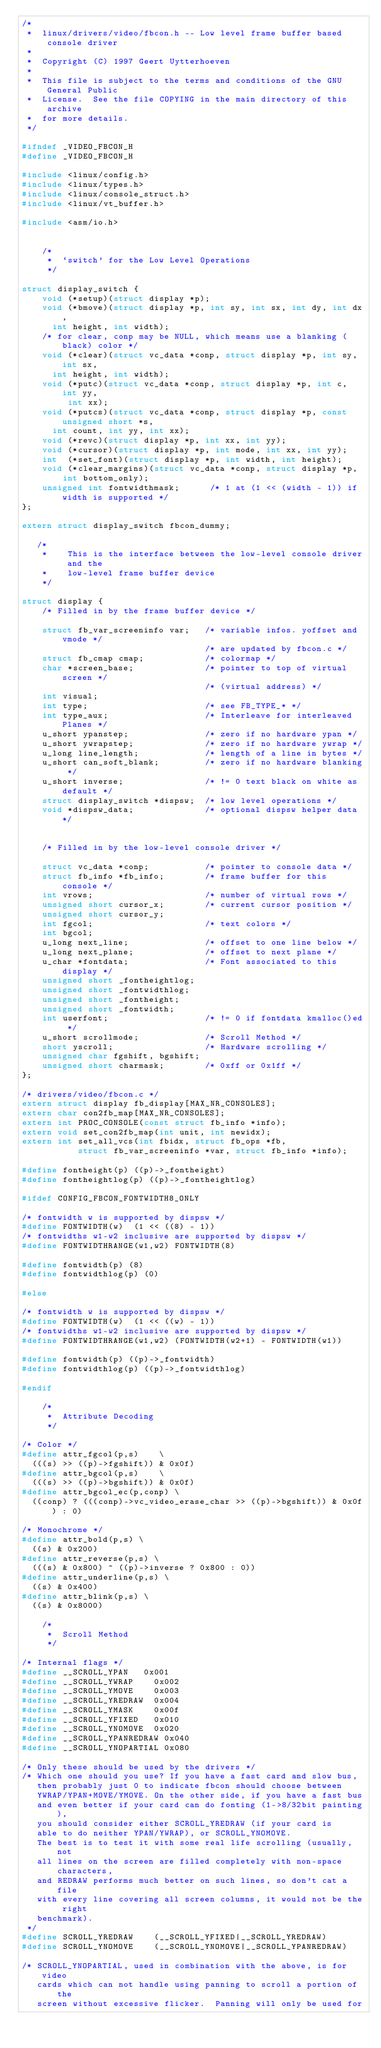Convert code to text. <code><loc_0><loc_0><loc_500><loc_500><_C_>/*
 *  linux/drivers/video/fbcon.h -- Low level frame buffer based console driver
 *
 *	Copyright (C) 1997 Geert Uytterhoeven
 *
 *  This file is subject to the terms and conditions of the GNU General Public
 *  License.  See the file COPYING in the main directory of this archive
 *  for more details.
 */

#ifndef _VIDEO_FBCON_H
#define _VIDEO_FBCON_H

#include <linux/config.h>
#include <linux/types.h>
#include <linux/console_struct.h>
#include <linux/vt_buffer.h>

#include <asm/io.h>


    /*                                  
     *  `switch' for the Low Level Operations
     */
 
struct display_switch {                                                
    void (*setup)(struct display *p);
    void (*bmove)(struct display *p, int sy, int sx, int dy, int dx,
		  int height, int width);
    /* for clear, conp may be NULL, which means use a blanking (black) color */
    void (*clear)(struct vc_data *conp, struct display *p, int sy, int sx,
		  int height, int width);
    void (*putc)(struct vc_data *conp, struct display *p, int c, int yy,
    		 int xx);
    void (*putcs)(struct vc_data *conp, struct display *p, const unsigned short *s,
		  int count, int yy, int xx);     
    void (*revc)(struct display *p, int xx, int yy);
    void (*cursor)(struct display *p, int mode, int xx, int yy);
    int  (*set_font)(struct display *p, int width, int height);
    void (*clear_margins)(struct vc_data *conp, struct display *p,
			  int bottom_only);
    unsigned int fontwidthmask;      /* 1 at (1 << (width - 1)) if width is supported */
}; 

extern struct display_switch fbcon_dummy;

   /*
    *    This is the interface between the low-level console driver and the
    *    low-level frame buffer device
    */

struct display {
    /* Filled in by the frame buffer device */

    struct fb_var_screeninfo var;   /* variable infos. yoffset and vmode */
                                    /* are updated by fbcon.c */
    struct fb_cmap cmap;            /* colormap */
    char *screen_base;              /* pointer to top of virtual screen */    
                                    /* (virtual address) */
    int visual;
    int type;                       /* see FB_TYPE_* */
    int type_aux;                   /* Interleave for interleaved Planes */
    u_short ypanstep;               /* zero if no hardware ypan */
    u_short ywrapstep;              /* zero if no hardware ywrap */
    u_long line_length;             /* length of a line in bytes */
    u_short can_soft_blank;         /* zero if no hardware blanking */
    u_short inverse;                /* != 0 text black on white as default */
    struct display_switch *dispsw;  /* low level operations */
    void *dispsw_data;              /* optional dispsw helper data */


    /* Filled in by the low-level console driver */

    struct vc_data *conp;           /* pointer to console data */
    struct fb_info *fb_info;        /* frame buffer for this console */
    int vrows;                      /* number of virtual rows */
    unsigned short cursor_x;        /* current cursor position */
    unsigned short cursor_y;
    int fgcol;                      /* text colors */
    int bgcol;
    u_long next_line;               /* offset to one line below */
    u_long next_plane;              /* offset to next plane */
    u_char *fontdata;               /* Font associated to this display */
    unsigned short _fontheightlog;
    unsigned short _fontwidthlog;
    unsigned short _fontheight;
    unsigned short _fontwidth;
    int userfont;                   /* != 0 if fontdata kmalloc()ed */
    u_short scrollmode;             /* Scroll Method */
    short yscroll;                  /* Hardware scrolling */
    unsigned char fgshift, bgshift;
    unsigned short charmask;        /* 0xff or 0x1ff */
};

/* drivers/video/fbcon.c */
extern struct display fb_display[MAX_NR_CONSOLES];
extern char con2fb_map[MAX_NR_CONSOLES];
extern int PROC_CONSOLE(const struct fb_info *info);
extern void set_con2fb_map(int unit, int newidx);
extern int set_all_vcs(int fbidx, struct fb_ops *fb,
		       struct fb_var_screeninfo *var, struct fb_info *info);

#define fontheight(p) ((p)->_fontheight)
#define fontheightlog(p) ((p)->_fontheightlog)

#ifdef CONFIG_FBCON_FONTWIDTH8_ONLY

/* fontwidth w is supported by dispsw */
#define FONTWIDTH(w)	(1 << ((8) - 1))
/* fontwidths w1-w2 inclusive are supported by dispsw */
#define FONTWIDTHRANGE(w1,w2)	FONTWIDTH(8)

#define fontwidth(p) (8)
#define fontwidthlog(p) (0)

#else

/* fontwidth w is supported by dispsw */
#define FONTWIDTH(w)	(1 << ((w) - 1))
/* fontwidths w1-w2 inclusive are supported by dispsw */
#define FONTWIDTHRANGE(w1,w2)	(FONTWIDTH(w2+1) - FONTWIDTH(w1))

#define fontwidth(p) ((p)->_fontwidth)
#define fontwidthlog(p) ((p)->_fontwidthlog)

#endif

    /*
     *  Attribute Decoding
     */

/* Color */
#define attr_fgcol(p,s)    \
	(((s) >> ((p)->fgshift)) & 0x0f)
#define attr_bgcol(p,s)    \
	(((s) >> ((p)->bgshift)) & 0x0f)
#define	attr_bgcol_ec(p,conp) \
	((conp) ? (((conp)->vc_video_erase_char >> ((p)->bgshift)) & 0x0f) : 0)

/* Monochrome */
#define attr_bold(p,s) \
	((s) & 0x200)
#define attr_reverse(p,s) \
	(((s) & 0x800) ^ ((p)->inverse ? 0x800 : 0))
#define attr_underline(p,s) \
	((s) & 0x400)
#define attr_blink(p,s) \
	((s) & 0x8000)
	
    /*
     *  Scroll Method
     */
     
/* Internal flags */
#define __SCROLL_YPAN		0x001
#define __SCROLL_YWRAP		0x002
#define __SCROLL_YMOVE		0x003
#define __SCROLL_YREDRAW	0x004
#define __SCROLL_YMASK		0x00f
#define __SCROLL_YFIXED		0x010
#define __SCROLL_YNOMOVE	0x020
#define __SCROLL_YPANREDRAW	0x040
#define __SCROLL_YNOPARTIAL	0x080

/* Only these should be used by the drivers */
/* Which one should you use? If you have a fast card and slow bus,
   then probably just 0 to indicate fbcon should choose between
   YWRAP/YPAN+MOVE/YMOVE. On the other side, if you have a fast bus
   and even better if your card can do fonting (1->8/32bit painting),
   you should consider either SCROLL_YREDRAW (if your card is
   able to do neither YPAN/YWRAP), or SCROLL_YNOMOVE.
   The best is to test it with some real life scrolling (usually, not
   all lines on the screen are filled completely with non-space characters,
   and REDRAW performs much better on such lines, so don't cat a file
   with every line covering all screen columns, it would not be the right
   benchmark).
 */
#define SCROLL_YREDRAW		(__SCROLL_YFIXED|__SCROLL_YREDRAW)
#define SCROLL_YNOMOVE		(__SCROLL_YNOMOVE|__SCROLL_YPANREDRAW)

/* SCROLL_YNOPARTIAL, used in combination with the above, is for video
   cards which can not handle using panning to scroll a portion of the
   screen without excessive flicker.  Panning will only be used for</code> 